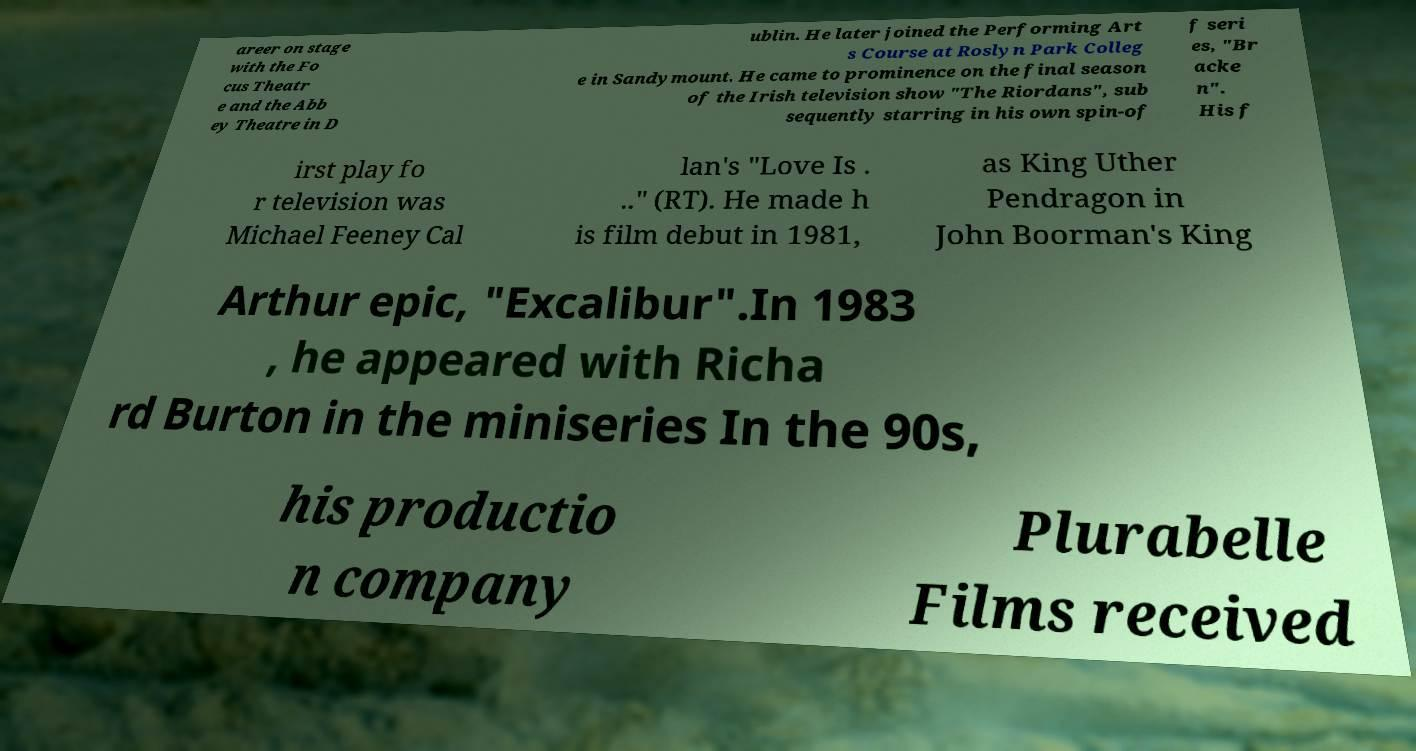Can you accurately transcribe the text from the provided image for me? areer on stage with the Fo cus Theatr e and the Abb ey Theatre in D ublin. He later joined the Performing Art s Course at Roslyn Park Colleg e in Sandymount. He came to prominence on the final season of the Irish television show "The Riordans", sub sequently starring in his own spin-of f seri es, "Br acke n". His f irst play fo r television was Michael Feeney Cal lan's "Love Is . .." (RT). He made h is film debut in 1981, as King Uther Pendragon in John Boorman's King Arthur epic, "Excalibur".In 1983 , he appeared with Richa rd Burton in the miniseries In the 90s, his productio n company Plurabelle Films received 